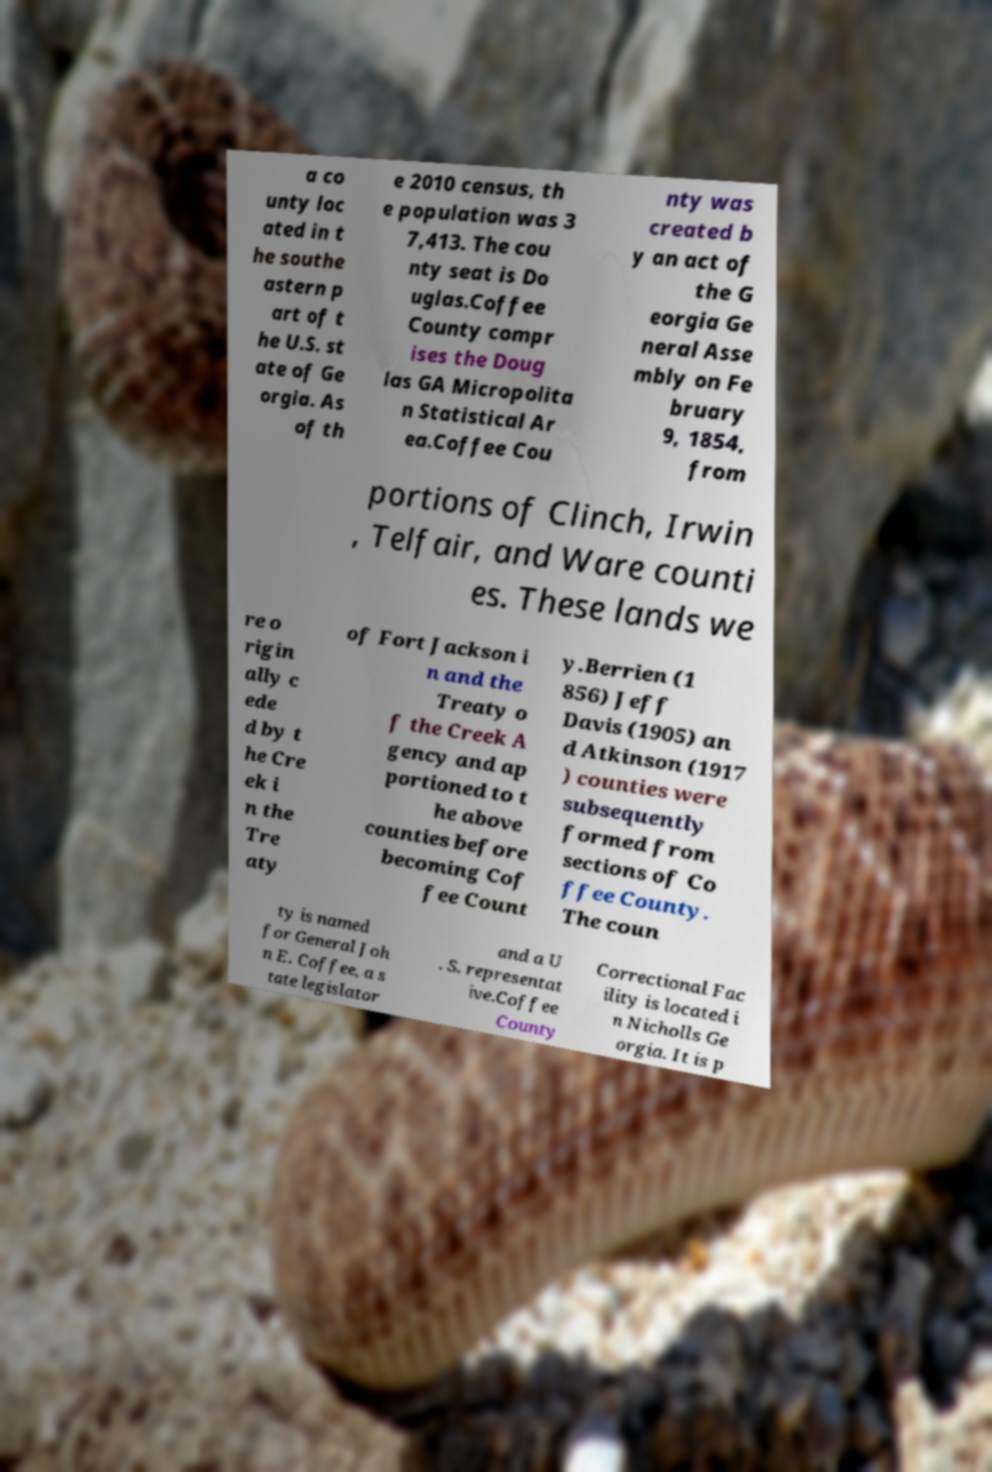There's text embedded in this image that I need extracted. Can you transcribe it verbatim? a co unty loc ated in t he southe astern p art of t he U.S. st ate of Ge orgia. As of th e 2010 census, th e population was 3 7,413. The cou nty seat is Do uglas.Coffee County compr ises the Doug las GA Micropolita n Statistical Ar ea.Coffee Cou nty was created b y an act of the G eorgia Ge neral Asse mbly on Fe bruary 9, 1854, from portions of Clinch, Irwin , Telfair, and Ware counti es. These lands we re o rigin ally c ede d by t he Cre ek i n the Tre aty of Fort Jackson i n and the Treaty o f the Creek A gency and ap portioned to t he above counties before becoming Cof fee Count y.Berrien (1 856) Jeff Davis (1905) an d Atkinson (1917 ) counties were subsequently formed from sections of Co ffee County. The coun ty is named for General Joh n E. Coffee, a s tate legislator and a U . S. representat ive.Coffee County Correctional Fac ility is located i n Nicholls Ge orgia. It is p 